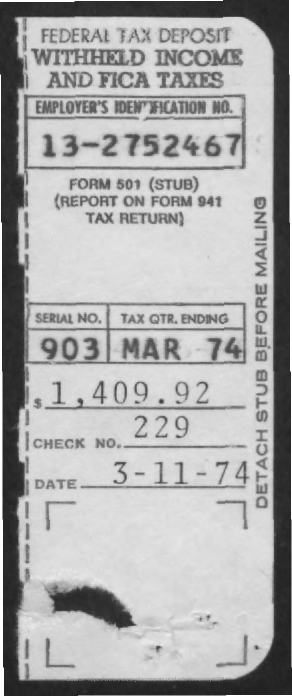How many $ were paid?
Ensure brevity in your answer.  1,409.92. What is the Check No. ?
Provide a succinct answer. 229. When tax was paid?
Keep it short and to the point. 3-11-74. 